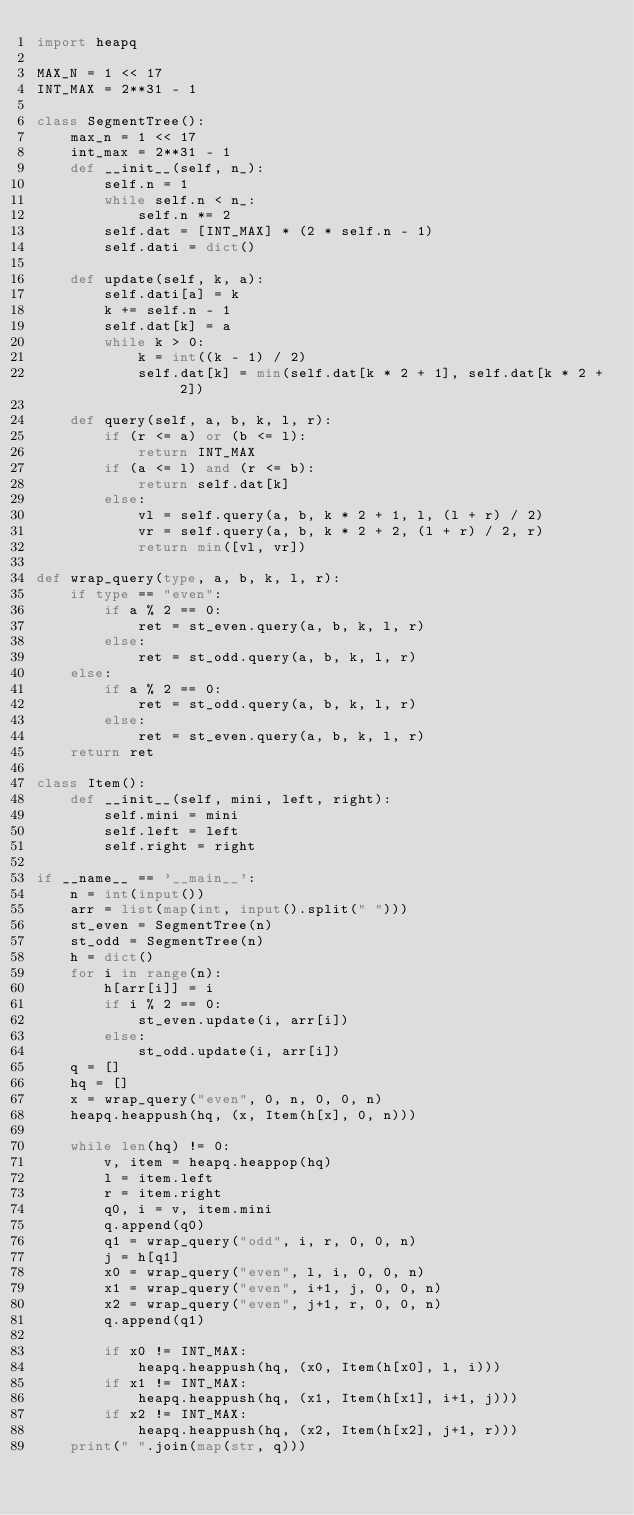<code> <loc_0><loc_0><loc_500><loc_500><_Python_>import heapq

MAX_N = 1 << 17
INT_MAX = 2**31 - 1

class SegmentTree():
    max_n = 1 << 17
    int_max = 2**31 - 1
    def __init__(self, n_):
        self.n = 1
        while self.n < n_:
            self.n *= 2
        self.dat = [INT_MAX] * (2 * self.n - 1)
        self.dati = dict()

    def update(self, k, a):
        self.dati[a] = k
        k += self.n - 1
        self.dat[k] = a
        while k > 0:
            k = int((k - 1) / 2)
            self.dat[k] = min(self.dat[k * 2 + 1], self.dat[k * 2 + 2])

    def query(self, a, b, k, l, r):
        if (r <= a) or (b <= l):
            return INT_MAX
        if (a <= l) and (r <= b):
            return self.dat[k]
        else:
            vl = self.query(a, b, k * 2 + 1, l, (l + r) / 2)
            vr = self.query(a, b, k * 2 + 2, (l + r) / 2, r)
            return min([vl, vr])

def wrap_query(type, a, b, k, l, r):
    if type == "even":
        if a % 2 == 0:
            ret = st_even.query(a, b, k, l, r)
        else:
            ret = st_odd.query(a, b, k, l, r)
    else:
        if a % 2 == 0:
            ret = st_odd.query(a, b, k, l, r)
        else:
            ret = st_even.query(a, b, k, l, r)
    return ret

class Item():
    def __init__(self, mini, left, right):
        self.mini = mini
        self.left = left
        self.right = right

if __name__ == '__main__':
    n = int(input())
    arr = list(map(int, input().split(" ")))
    st_even = SegmentTree(n)
    st_odd = SegmentTree(n)
    h = dict()
    for i in range(n):
        h[arr[i]] = i
        if i % 2 == 0:
            st_even.update(i, arr[i])
        else:
            st_odd.update(i, arr[i])
    q = []
    hq = []
    x = wrap_query("even", 0, n, 0, 0, n)
    heapq.heappush(hq, (x, Item(h[x], 0, n)))

    while len(hq) != 0:
        v, item = heapq.heappop(hq)
        l = item.left
        r = item.right
        q0, i = v, item.mini
        q.append(q0)
        q1 = wrap_query("odd", i, r, 0, 0, n)
        j = h[q1]
        x0 = wrap_query("even", l, i, 0, 0, n)
        x1 = wrap_query("even", i+1, j, 0, 0, n)
        x2 = wrap_query("even", j+1, r, 0, 0, n)
        q.append(q1)

        if x0 != INT_MAX:
            heapq.heappush(hq, (x0, Item(h[x0], l, i)))
        if x1 != INT_MAX:
            heapq.heappush(hq, (x1, Item(h[x1], i+1, j)))
        if x2 != INT_MAX:
            heapq.heappush(hq, (x2, Item(h[x2], j+1, r)))
    print(" ".join(map(str, q)))</code> 